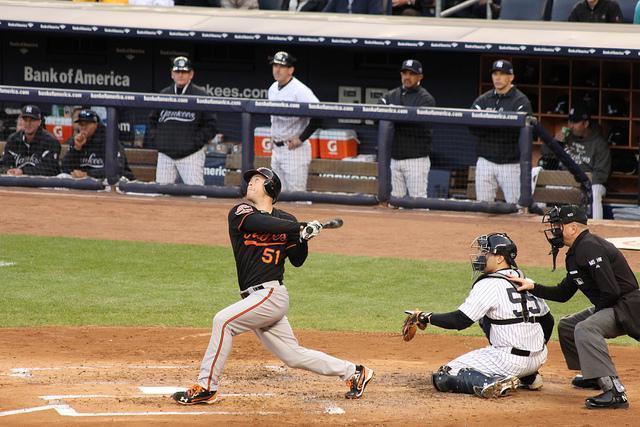What holds the beverages for the players in the dugout?
Indicate the correct response by choosing from the four available options to answer the question.
Options: Coolers, shelves, umpire, fans. Coolers. 